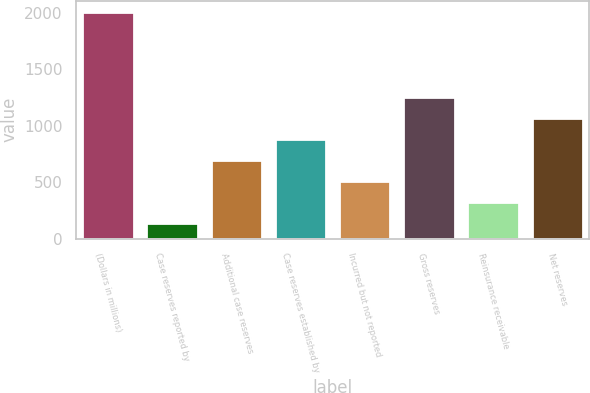Convert chart. <chart><loc_0><loc_0><loc_500><loc_500><bar_chart><fcel>(Dollars in millions)<fcel>Case reserves reported by<fcel>Additional case reserves<fcel>Case reserves established by<fcel>Incurred but not reported<fcel>Gross reserves<fcel>Reinsurance receivable<fcel>Net reserves<nl><fcel>2006<fcel>135.6<fcel>696.72<fcel>883.76<fcel>509.68<fcel>1257.84<fcel>322.64<fcel>1070.8<nl></chart> 